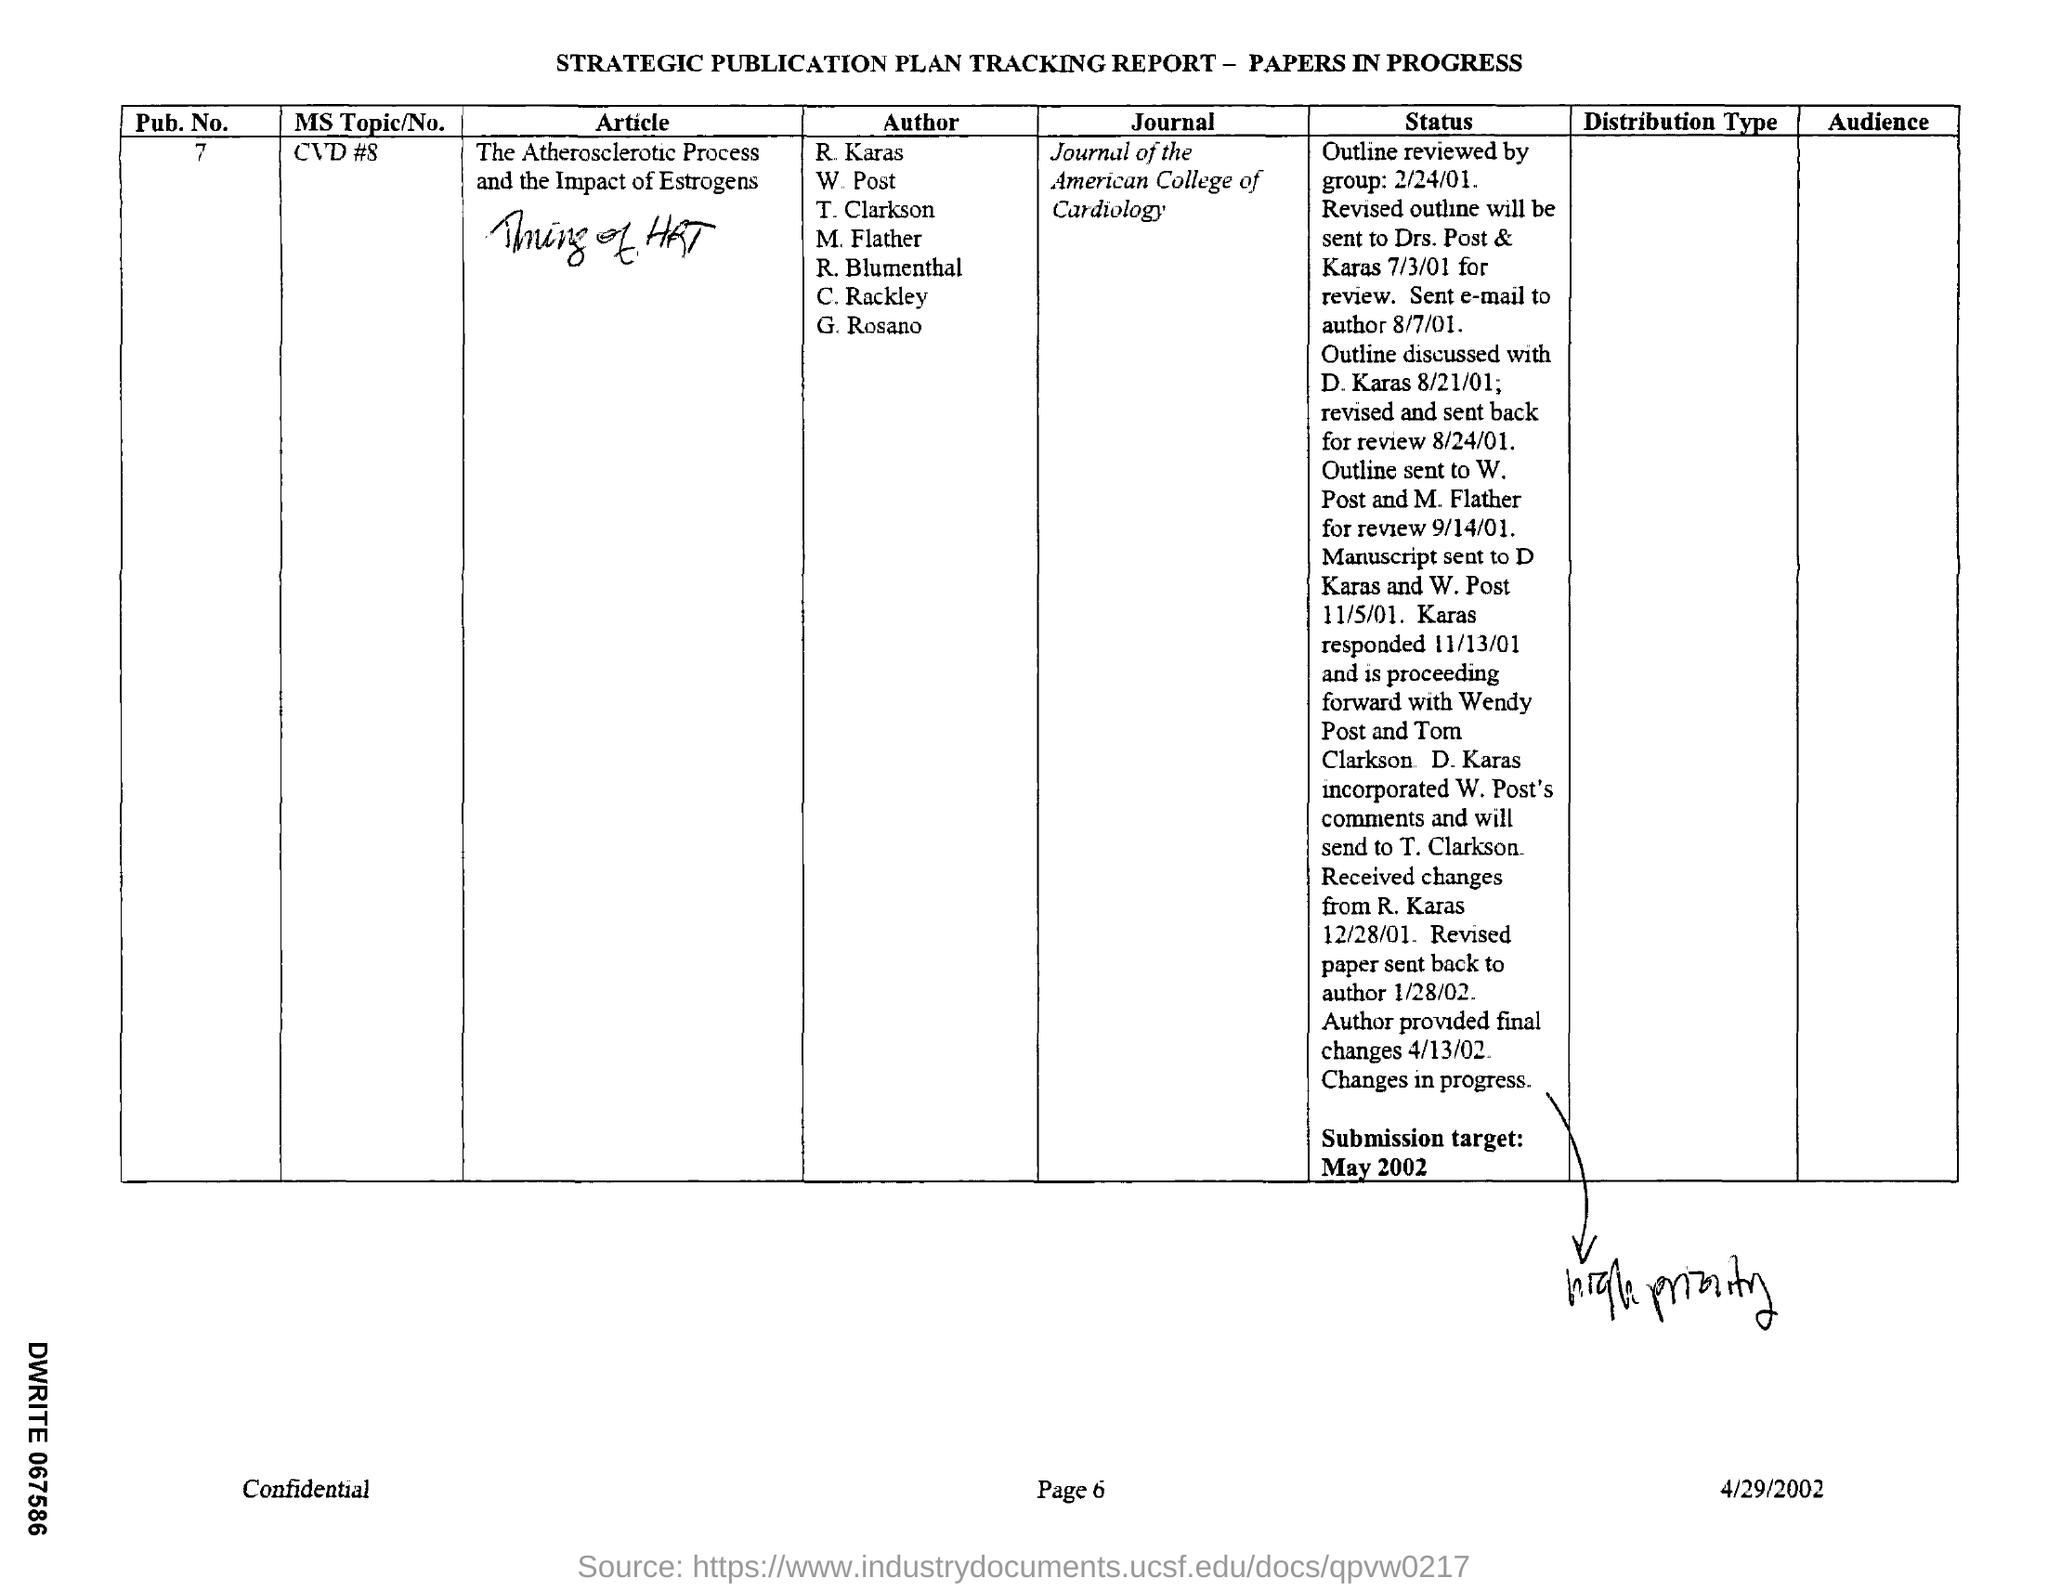Mention a couple of crucial points in this snapshot. The article mentioned in the given report is called "The Atherosclerotic Process and the Impact of Estrogens. The topic of MS is not mentioned in the given report, nor is the number 8 mentioned in relation to CVD (cardiovascular disease). The journal mentioned in the tracking report is the Journal of the American College of Cardiology. The reported tracking includes a reference to a pub .no. of 7.. The submission target is mentioned in the report, and it is May 2002. 